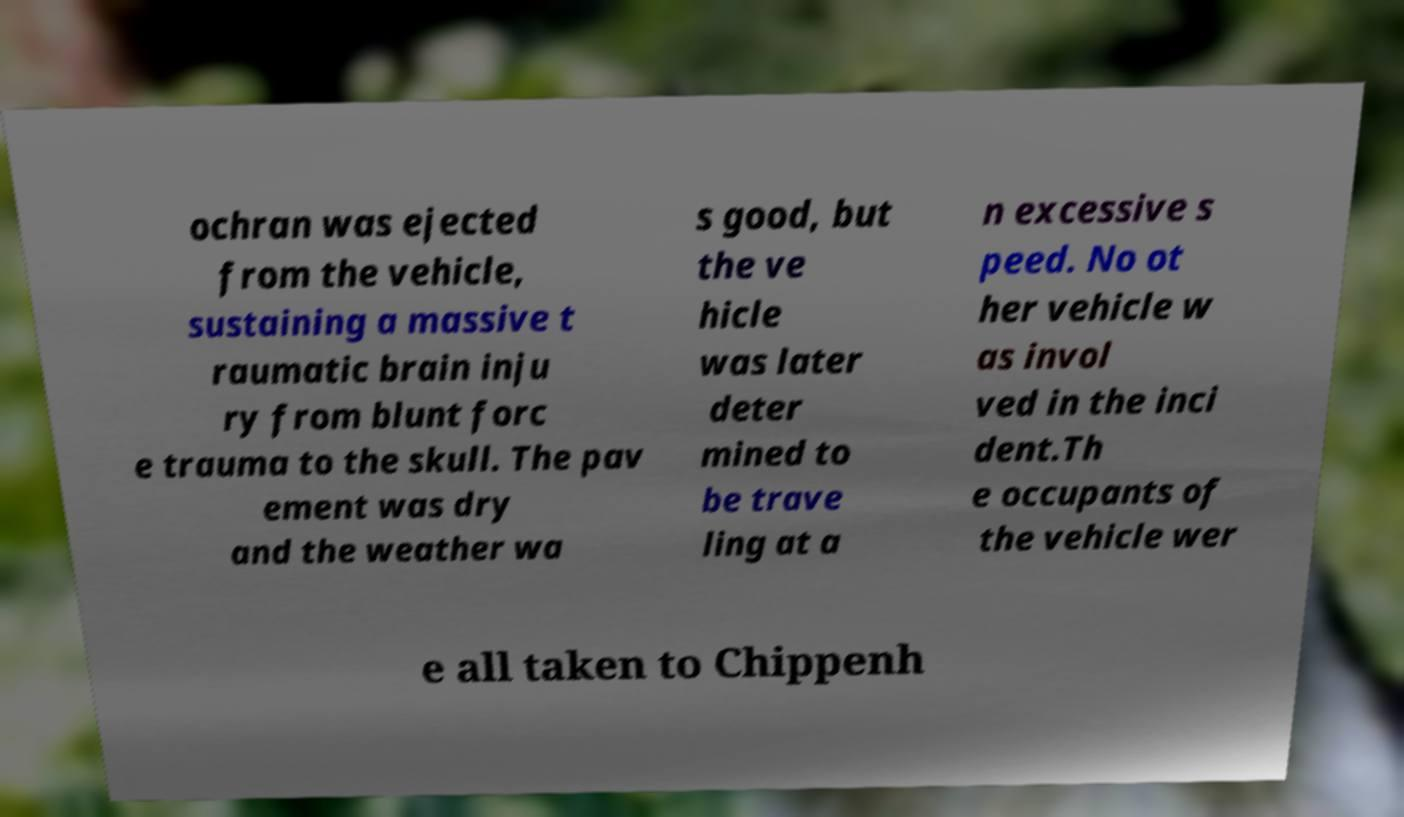Could you assist in decoding the text presented in this image and type it out clearly? ochran was ejected from the vehicle, sustaining a massive t raumatic brain inju ry from blunt forc e trauma to the skull. The pav ement was dry and the weather wa s good, but the ve hicle was later deter mined to be trave ling at a n excessive s peed. No ot her vehicle w as invol ved in the inci dent.Th e occupants of the vehicle wer e all taken to Chippenh 